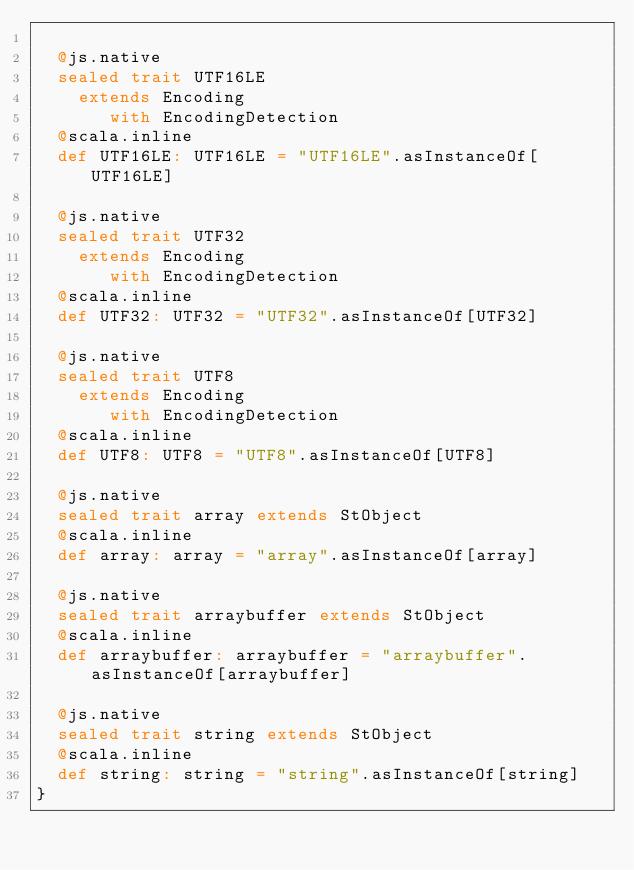Convert code to text. <code><loc_0><loc_0><loc_500><loc_500><_Scala_>  
  @js.native
  sealed trait UTF16LE
    extends Encoding
       with EncodingDetection
  @scala.inline
  def UTF16LE: UTF16LE = "UTF16LE".asInstanceOf[UTF16LE]
  
  @js.native
  sealed trait UTF32
    extends Encoding
       with EncodingDetection
  @scala.inline
  def UTF32: UTF32 = "UTF32".asInstanceOf[UTF32]
  
  @js.native
  sealed trait UTF8
    extends Encoding
       with EncodingDetection
  @scala.inline
  def UTF8: UTF8 = "UTF8".asInstanceOf[UTF8]
  
  @js.native
  sealed trait array extends StObject
  @scala.inline
  def array: array = "array".asInstanceOf[array]
  
  @js.native
  sealed trait arraybuffer extends StObject
  @scala.inline
  def arraybuffer: arraybuffer = "arraybuffer".asInstanceOf[arraybuffer]
  
  @js.native
  sealed trait string extends StObject
  @scala.inline
  def string: string = "string".asInstanceOf[string]
}
</code> 